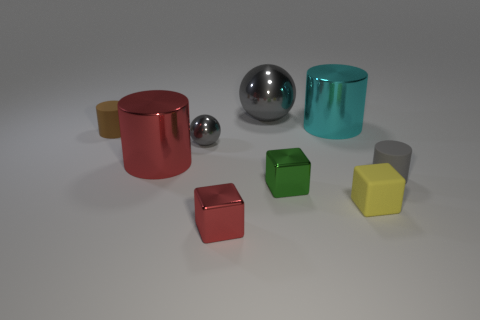Subtract all blue cylinders. Subtract all yellow spheres. How many cylinders are left? 4 Add 1 cylinders. How many objects exist? 10 Subtract all blocks. How many objects are left? 6 Add 1 tiny gray matte things. How many tiny gray matte things are left? 2 Add 2 large brown cubes. How many large brown cubes exist? 2 Subtract 0 purple cylinders. How many objects are left? 9 Subtract all cyan cylinders. Subtract all big cyan metallic objects. How many objects are left? 7 